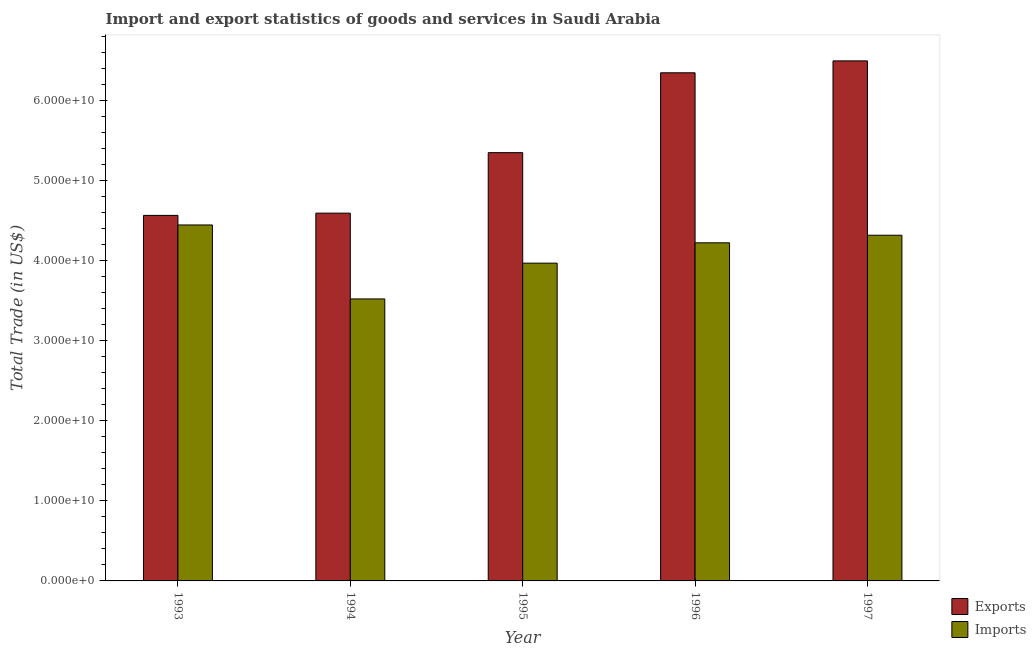How many groups of bars are there?
Keep it short and to the point. 5. Are the number of bars on each tick of the X-axis equal?
Your response must be concise. Yes. What is the label of the 2nd group of bars from the left?
Your answer should be compact. 1994. What is the export of goods and services in 1997?
Keep it short and to the point. 6.50e+1. Across all years, what is the maximum export of goods and services?
Make the answer very short. 6.50e+1. Across all years, what is the minimum imports of goods and services?
Ensure brevity in your answer.  3.52e+1. In which year was the imports of goods and services maximum?
Your answer should be compact. 1993. In which year was the imports of goods and services minimum?
Make the answer very short. 1994. What is the total export of goods and services in the graph?
Your answer should be very brief. 2.74e+11. What is the difference between the export of goods and services in 1994 and that in 1995?
Your response must be concise. -7.56e+09. What is the difference between the export of goods and services in 1993 and the imports of goods and services in 1996?
Provide a succinct answer. -1.78e+1. What is the average export of goods and services per year?
Ensure brevity in your answer.  5.47e+1. In the year 1994, what is the difference between the export of goods and services and imports of goods and services?
Offer a very short reply. 0. In how many years, is the export of goods and services greater than 26000000000 US$?
Give a very brief answer. 5. What is the ratio of the export of goods and services in 1995 to that in 1997?
Your answer should be very brief. 0.82. What is the difference between the highest and the second highest imports of goods and services?
Your response must be concise. 1.28e+09. What is the difference between the highest and the lowest export of goods and services?
Your answer should be very brief. 1.93e+1. In how many years, is the export of goods and services greater than the average export of goods and services taken over all years?
Provide a succinct answer. 2. What does the 1st bar from the left in 1996 represents?
Provide a succinct answer. Exports. What does the 2nd bar from the right in 1997 represents?
Make the answer very short. Exports. How many bars are there?
Provide a short and direct response. 10. Are all the bars in the graph horizontal?
Provide a short and direct response. No. Does the graph contain any zero values?
Your response must be concise. No. Does the graph contain grids?
Your answer should be compact. No. Where does the legend appear in the graph?
Give a very brief answer. Bottom right. How are the legend labels stacked?
Ensure brevity in your answer.  Vertical. What is the title of the graph?
Provide a succinct answer. Import and export statistics of goods and services in Saudi Arabia. What is the label or title of the X-axis?
Give a very brief answer. Year. What is the label or title of the Y-axis?
Your answer should be compact. Total Trade (in US$). What is the Total Trade (in US$) of Exports in 1993?
Keep it short and to the point. 4.57e+1. What is the Total Trade (in US$) of Imports in 1993?
Provide a short and direct response. 4.45e+1. What is the Total Trade (in US$) of Exports in 1994?
Your answer should be compact. 4.60e+1. What is the Total Trade (in US$) in Imports in 1994?
Offer a terse response. 3.52e+1. What is the Total Trade (in US$) of Exports in 1995?
Make the answer very short. 5.35e+1. What is the Total Trade (in US$) in Imports in 1995?
Your answer should be compact. 3.97e+1. What is the Total Trade (in US$) of Exports in 1996?
Offer a terse response. 6.35e+1. What is the Total Trade (in US$) in Imports in 1996?
Provide a short and direct response. 4.23e+1. What is the Total Trade (in US$) in Exports in 1997?
Provide a succinct answer. 6.50e+1. What is the Total Trade (in US$) of Imports in 1997?
Give a very brief answer. 4.32e+1. Across all years, what is the maximum Total Trade (in US$) in Exports?
Offer a very short reply. 6.50e+1. Across all years, what is the maximum Total Trade (in US$) of Imports?
Offer a terse response. 4.45e+1. Across all years, what is the minimum Total Trade (in US$) of Exports?
Provide a short and direct response. 4.57e+1. Across all years, what is the minimum Total Trade (in US$) in Imports?
Your answer should be very brief. 3.52e+1. What is the total Total Trade (in US$) of Exports in the graph?
Make the answer very short. 2.74e+11. What is the total Total Trade (in US$) of Imports in the graph?
Your answer should be very brief. 2.05e+11. What is the difference between the Total Trade (in US$) of Exports in 1993 and that in 1994?
Give a very brief answer. -2.83e+08. What is the difference between the Total Trade (in US$) in Imports in 1993 and that in 1994?
Keep it short and to the point. 9.24e+09. What is the difference between the Total Trade (in US$) in Exports in 1993 and that in 1995?
Ensure brevity in your answer.  -7.84e+09. What is the difference between the Total Trade (in US$) of Imports in 1993 and that in 1995?
Give a very brief answer. 4.77e+09. What is the difference between the Total Trade (in US$) of Exports in 1993 and that in 1996?
Provide a short and direct response. -1.78e+1. What is the difference between the Total Trade (in US$) in Imports in 1993 and that in 1996?
Give a very brief answer. 2.23e+09. What is the difference between the Total Trade (in US$) of Exports in 1993 and that in 1997?
Give a very brief answer. -1.93e+1. What is the difference between the Total Trade (in US$) of Imports in 1993 and that in 1997?
Give a very brief answer. 1.28e+09. What is the difference between the Total Trade (in US$) of Exports in 1994 and that in 1995?
Ensure brevity in your answer.  -7.56e+09. What is the difference between the Total Trade (in US$) in Imports in 1994 and that in 1995?
Your answer should be compact. -4.47e+09. What is the difference between the Total Trade (in US$) of Exports in 1994 and that in 1996?
Keep it short and to the point. -1.75e+1. What is the difference between the Total Trade (in US$) of Imports in 1994 and that in 1996?
Provide a succinct answer. -7.01e+09. What is the difference between the Total Trade (in US$) of Exports in 1994 and that in 1997?
Your answer should be very brief. -1.90e+1. What is the difference between the Total Trade (in US$) in Imports in 1994 and that in 1997?
Ensure brevity in your answer.  -7.96e+09. What is the difference between the Total Trade (in US$) in Exports in 1995 and that in 1996?
Offer a very short reply. -9.98e+09. What is the difference between the Total Trade (in US$) in Imports in 1995 and that in 1996?
Your response must be concise. -2.54e+09. What is the difference between the Total Trade (in US$) of Exports in 1995 and that in 1997?
Give a very brief answer. -1.15e+1. What is the difference between the Total Trade (in US$) in Imports in 1995 and that in 1997?
Provide a short and direct response. -3.49e+09. What is the difference between the Total Trade (in US$) in Exports in 1996 and that in 1997?
Your answer should be compact. -1.49e+09. What is the difference between the Total Trade (in US$) of Imports in 1996 and that in 1997?
Ensure brevity in your answer.  -9.46e+08. What is the difference between the Total Trade (in US$) of Exports in 1993 and the Total Trade (in US$) of Imports in 1994?
Your answer should be compact. 1.04e+1. What is the difference between the Total Trade (in US$) in Exports in 1993 and the Total Trade (in US$) in Imports in 1995?
Provide a short and direct response. 5.97e+09. What is the difference between the Total Trade (in US$) of Exports in 1993 and the Total Trade (in US$) of Imports in 1996?
Offer a very short reply. 3.42e+09. What is the difference between the Total Trade (in US$) of Exports in 1993 and the Total Trade (in US$) of Imports in 1997?
Provide a short and direct response. 2.48e+09. What is the difference between the Total Trade (in US$) of Exports in 1994 and the Total Trade (in US$) of Imports in 1995?
Ensure brevity in your answer.  6.25e+09. What is the difference between the Total Trade (in US$) in Exports in 1994 and the Total Trade (in US$) in Imports in 1996?
Provide a short and direct response. 3.71e+09. What is the difference between the Total Trade (in US$) in Exports in 1994 and the Total Trade (in US$) in Imports in 1997?
Provide a succinct answer. 2.76e+09. What is the difference between the Total Trade (in US$) of Exports in 1995 and the Total Trade (in US$) of Imports in 1996?
Provide a short and direct response. 1.13e+1. What is the difference between the Total Trade (in US$) of Exports in 1995 and the Total Trade (in US$) of Imports in 1997?
Your response must be concise. 1.03e+1. What is the difference between the Total Trade (in US$) in Exports in 1996 and the Total Trade (in US$) in Imports in 1997?
Keep it short and to the point. 2.03e+1. What is the average Total Trade (in US$) of Exports per year?
Make the answer very short. 5.47e+1. What is the average Total Trade (in US$) in Imports per year?
Provide a succinct answer. 4.10e+1. In the year 1993, what is the difference between the Total Trade (in US$) of Exports and Total Trade (in US$) of Imports?
Make the answer very short. 1.19e+09. In the year 1994, what is the difference between the Total Trade (in US$) in Exports and Total Trade (in US$) in Imports?
Give a very brief answer. 1.07e+1. In the year 1995, what is the difference between the Total Trade (in US$) in Exports and Total Trade (in US$) in Imports?
Provide a succinct answer. 1.38e+1. In the year 1996, what is the difference between the Total Trade (in US$) of Exports and Total Trade (in US$) of Imports?
Offer a very short reply. 2.12e+1. In the year 1997, what is the difference between the Total Trade (in US$) of Exports and Total Trade (in US$) of Imports?
Ensure brevity in your answer.  2.18e+1. What is the ratio of the Total Trade (in US$) in Exports in 1993 to that in 1994?
Offer a terse response. 0.99. What is the ratio of the Total Trade (in US$) in Imports in 1993 to that in 1994?
Keep it short and to the point. 1.26. What is the ratio of the Total Trade (in US$) of Exports in 1993 to that in 1995?
Provide a short and direct response. 0.85. What is the ratio of the Total Trade (in US$) in Imports in 1993 to that in 1995?
Provide a succinct answer. 1.12. What is the ratio of the Total Trade (in US$) in Exports in 1993 to that in 1996?
Offer a terse response. 0.72. What is the ratio of the Total Trade (in US$) of Imports in 1993 to that in 1996?
Your answer should be compact. 1.05. What is the ratio of the Total Trade (in US$) in Exports in 1993 to that in 1997?
Your response must be concise. 0.7. What is the ratio of the Total Trade (in US$) of Imports in 1993 to that in 1997?
Keep it short and to the point. 1.03. What is the ratio of the Total Trade (in US$) of Exports in 1994 to that in 1995?
Your response must be concise. 0.86. What is the ratio of the Total Trade (in US$) of Imports in 1994 to that in 1995?
Offer a terse response. 0.89. What is the ratio of the Total Trade (in US$) in Exports in 1994 to that in 1996?
Offer a very short reply. 0.72. What is the ratio of the Total Trade (in US$) of Imports in 1994 to that in 1996?
Your response must be concise. 0.83. What is the ratio of the Total Trade (in US$) of Exports in 1994 to that in 1997?
Your response must be concise. 0.71. What is the ratio of the Total Trade (in US$) of Imports in 1994 to that in 1997?
Make the answer very short. 0.82. What is the ratio of the Total Trade (in US$) in Exports in 1995 to that in 1996?
Give a very brief answer. 0.84. What is the ratio of the Total Trade (in US$) in Imports in 1995 to that in 1996?
Provide a short and direct response. 0.94. What is the ratio of the Total Trade (in US$) of Exports in 1995 to that in 1997?
Offer a very short reply. 0.82. What is the ratio of the Total Trade (in US$) of Imports in 1995 to that in 1997?
Ensure brevity in your answer.  0.92. What is the ratio of the Total Trade (in US$) of Exports in 1996 to that in 1997?
Ensure brevity in your answer.  0.98. What is the ratio of the Total Trade (in US$) of Imports in 1996 to that in 1997?
Ensure brevity in your answer.  0.98. What is the difference between the highest and the second highest Total Trade (in US$) of Exports?
Your response must be concise. 1.49e+09. What is the difference between the highest and the second highest Total Trade (in US$) of Imports?
Make the answer very short. 1.28e+09. What is the difference between the highest and the lowest Total Trade (in US$) in Exports?
Provide a succinct answer. 1.93e+1. What is the difference between the highest and the lowest Total Trade (in US$) of Imports?
Ensure brevity in your answer.  9.24e+09. 